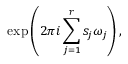<formula> <loc_0><loc_0><loc_500><loc_500>\exp \left ( 2 \pi i \sum _ { j = 1 } ^ { r } s _ { j } \omega _ { j } \right ) ,</formula> 